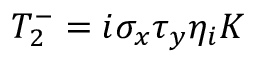<formula> <loc_0><loc_0><loc_500><loc_500>T _ { 2 } ^ { - } = i \sigma _ { x } \tau _ { y } \eta _ { i } K</formula> 